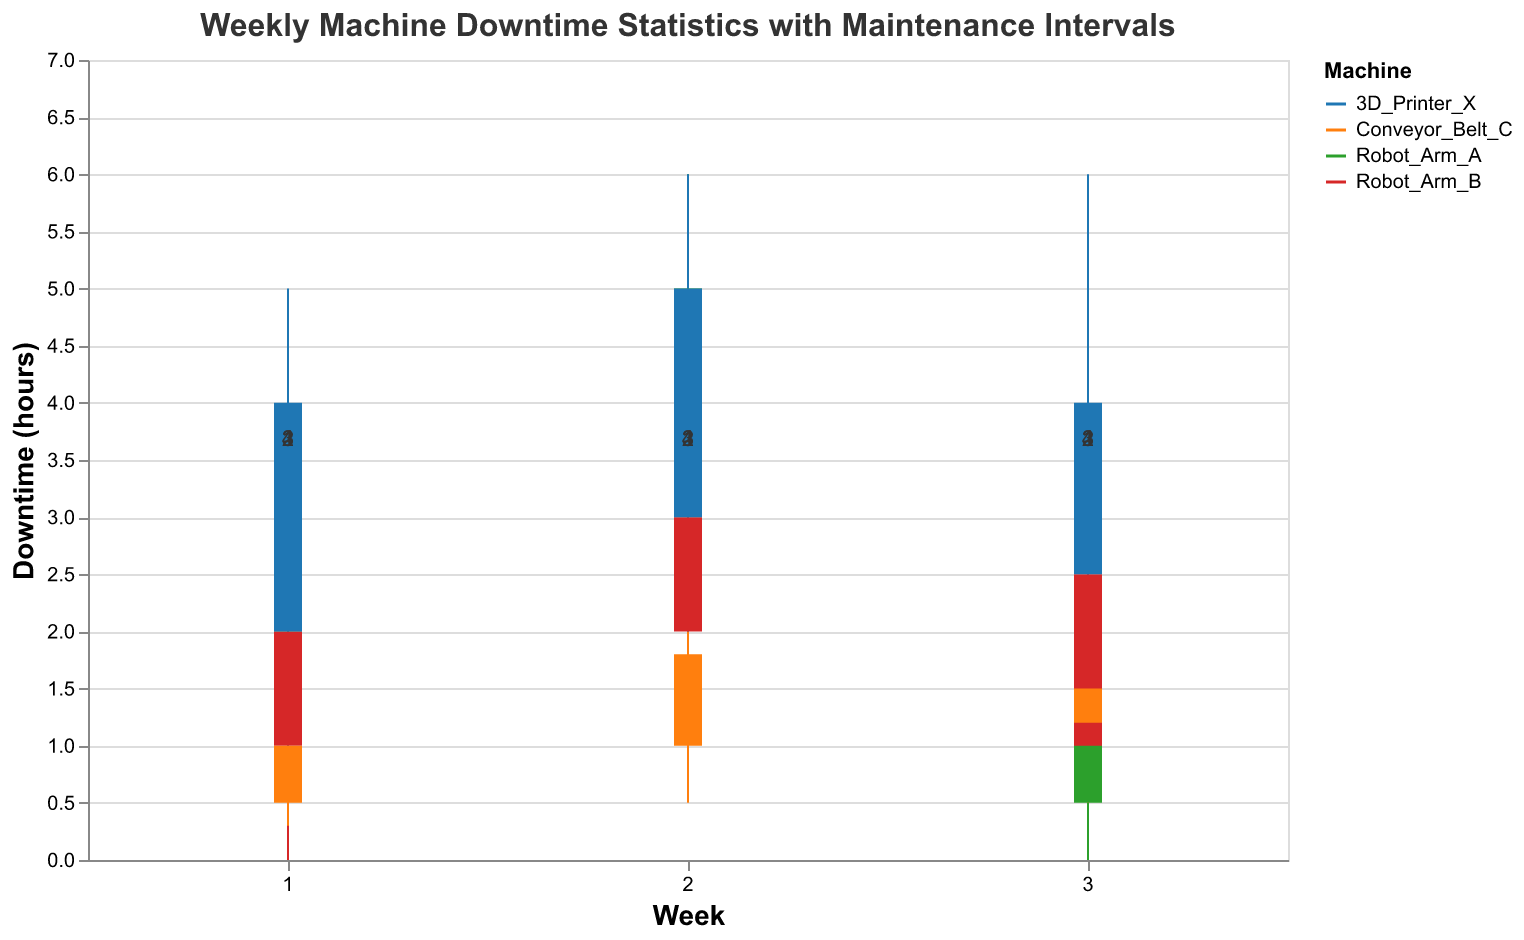What is the title of the figure? The title of the figure is typically displayed at the top of the chart. We can see from the description that the title is "Weekly Machine Downtime Statistics with Maintenance Intervals".
Answer: Weekly Machine Downtime Statistics with Maintenance Intervals What is the maximum downtime experienced by Robot_Arm_A in week 2? To find the maximum downtime, we look at the "High" value in week 2 for Robot_Arm_A, which is 6 hours.
Answer: 6 hours Which machine had the least amount of downtime in week 3? By comparing the "Low" values for all machines in week 3, we see that Robot_Arm_A had the least downtime with a low of 0 hours.
Answer: Robot_Arm_A Among all the machines, which one had the highest downtime in any given week? To find the maximum downtime, we identify the highest "High" value among all machines across all weeks. The highest recorded downtime is 6 hours, which occurs for Robot_Arm_A in week 2, 3D_Printer_X in weeks 1, 2, and 3.
Answer: Robot_Arm_A and 3D_Printer_X What was the total downtime range for Conveyor_Belt_C over the three weeks? We determine the range by finding the difference between the highest "High" and the lowest "Low" values over the three weeks for Conveyor_Belt_C. The highest is 2.5 hours, and the lowest is 0.3 hours, so the range is 2.5 - 0.3 = 2.2 hours.
Answer: 2.2 hours Which machine's downtime improved the most from week 1 to week 3? To find improvements, we compare the "Close" values between week 1 and week 3 for each machine. Robot_Arm_A went from 3 to 1.5 (improvement of 1.5 hours), Robot_Arm_B from 2 to 2.5 (no improvement), Conveyor_Belt_C from 1 to 1.5 (no improvement), and 3D_Printer_X from 4 to 4 (no improvement). Robot_Arm_A shows the most improvement.
Answer: Robot_Arm_A What is the average maintenance interval for the machines in week 3? To find the average maintenance interval, sum up the maintenance intervals for all machines in week 3 and divide by the number of machines. The intervals are 3, 2, 1, and 4. The sum is 3 + 2 + 1 + 4 = 10, hence the average is 10 / 4 = 2.5.
Answer: 2.5 Which machine had a consistent "High" downtime value over the three weeks? Observing the "High" values for each machine, 3D_Printer_X consistently had a high downtime of 6 hours across all three weeks (weeks 1, 2, and 3).
Answer: 3D_Printer_X What is the range of downtime for 3D_Printer_X in week 1? The range of downtime can be found by subtracting the "Low" value from the "High" value for 3D_Printer_X in week 1. The "High" is 5 hours and the "Low" is 1 hour, so the range is 5 - 1 = 4 hours.
Answer: 4 hours 